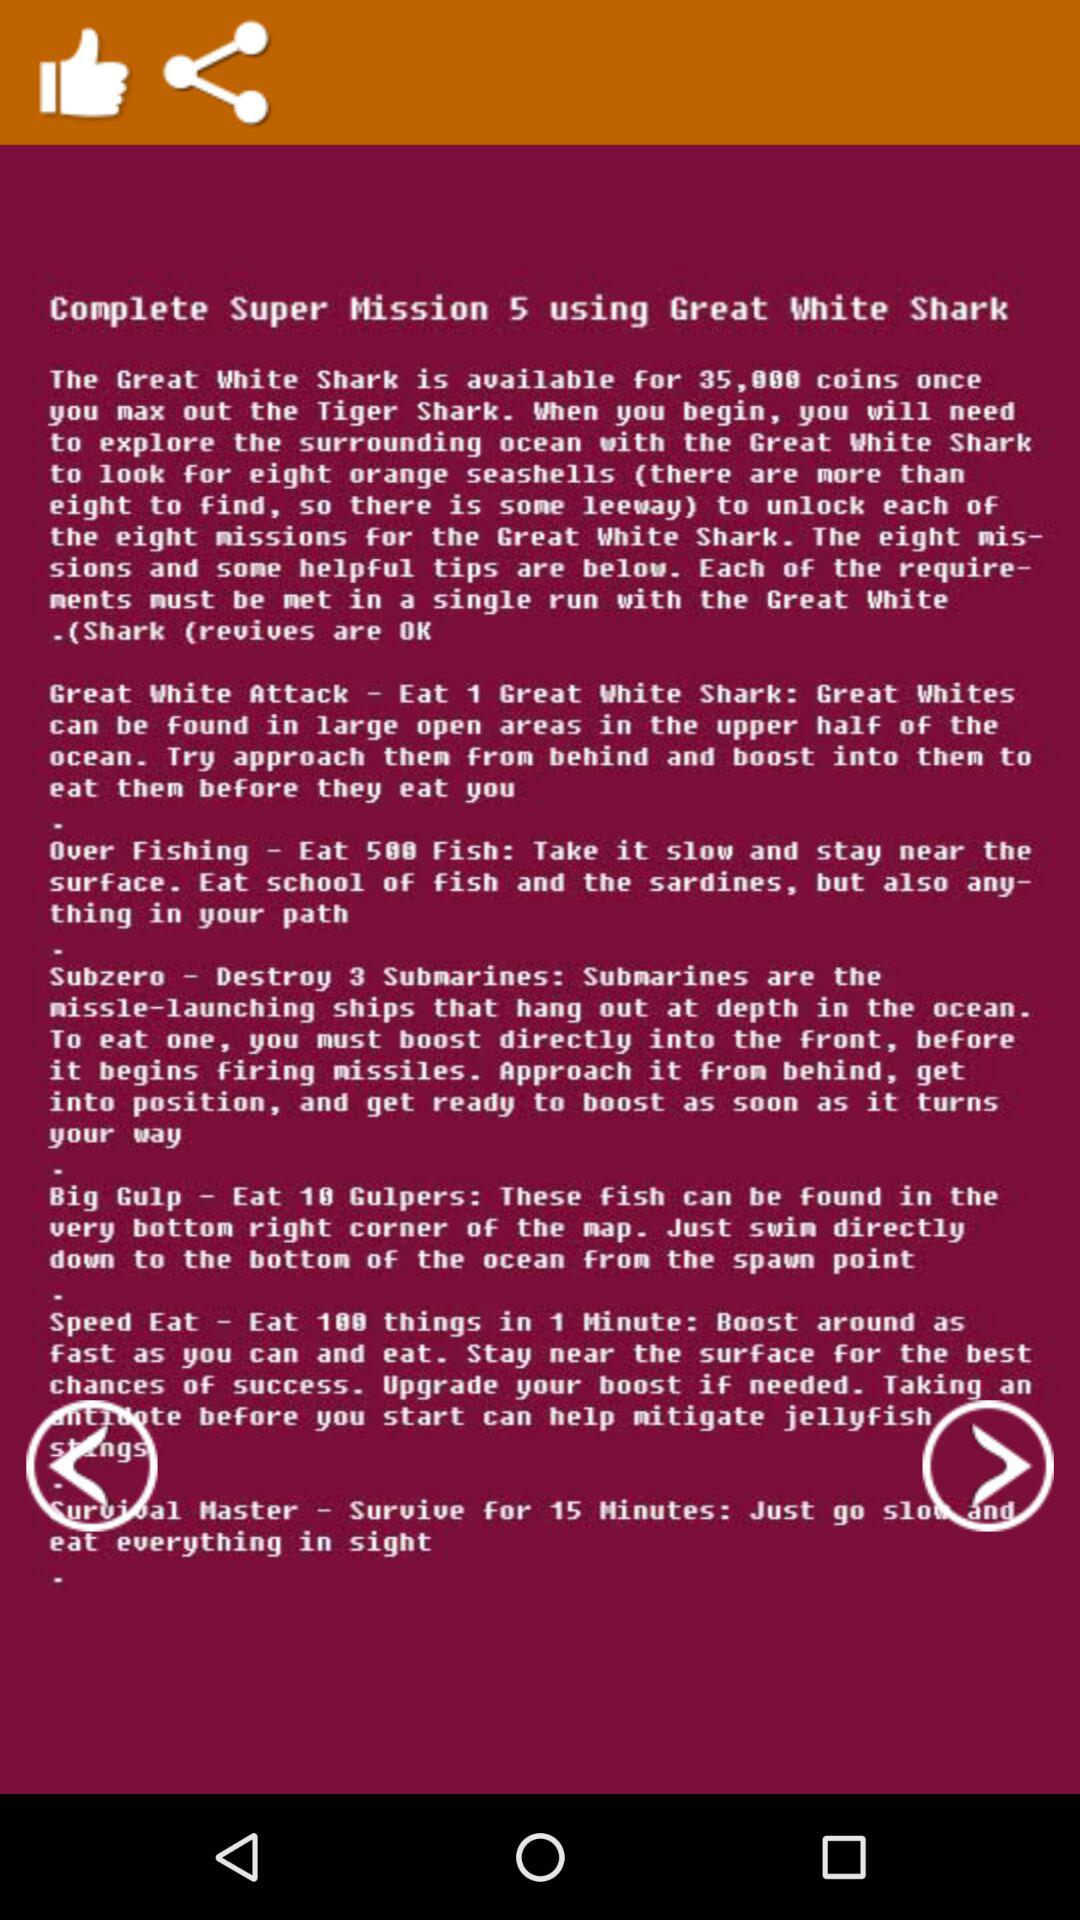How many missions are there for the Great White Shark?
Answer the question using a single word or phrase. 8 